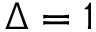Convert formula to latex. <formula><loc_0><loc_0><loc_500><loc_500>\Delta = 1</formula> 